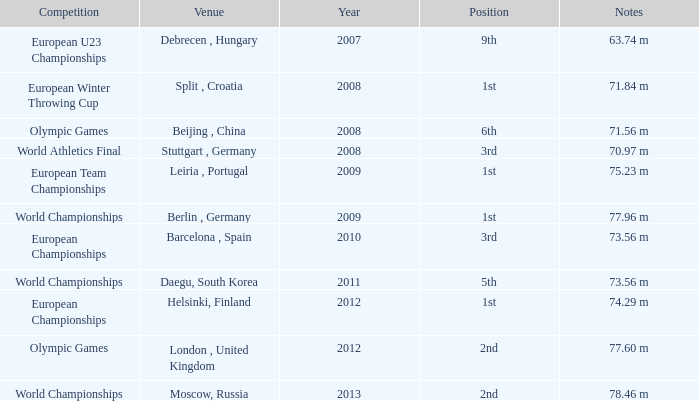Which Notes have a Competition of world championships, and a Position of 2nd? 78.46 m. 